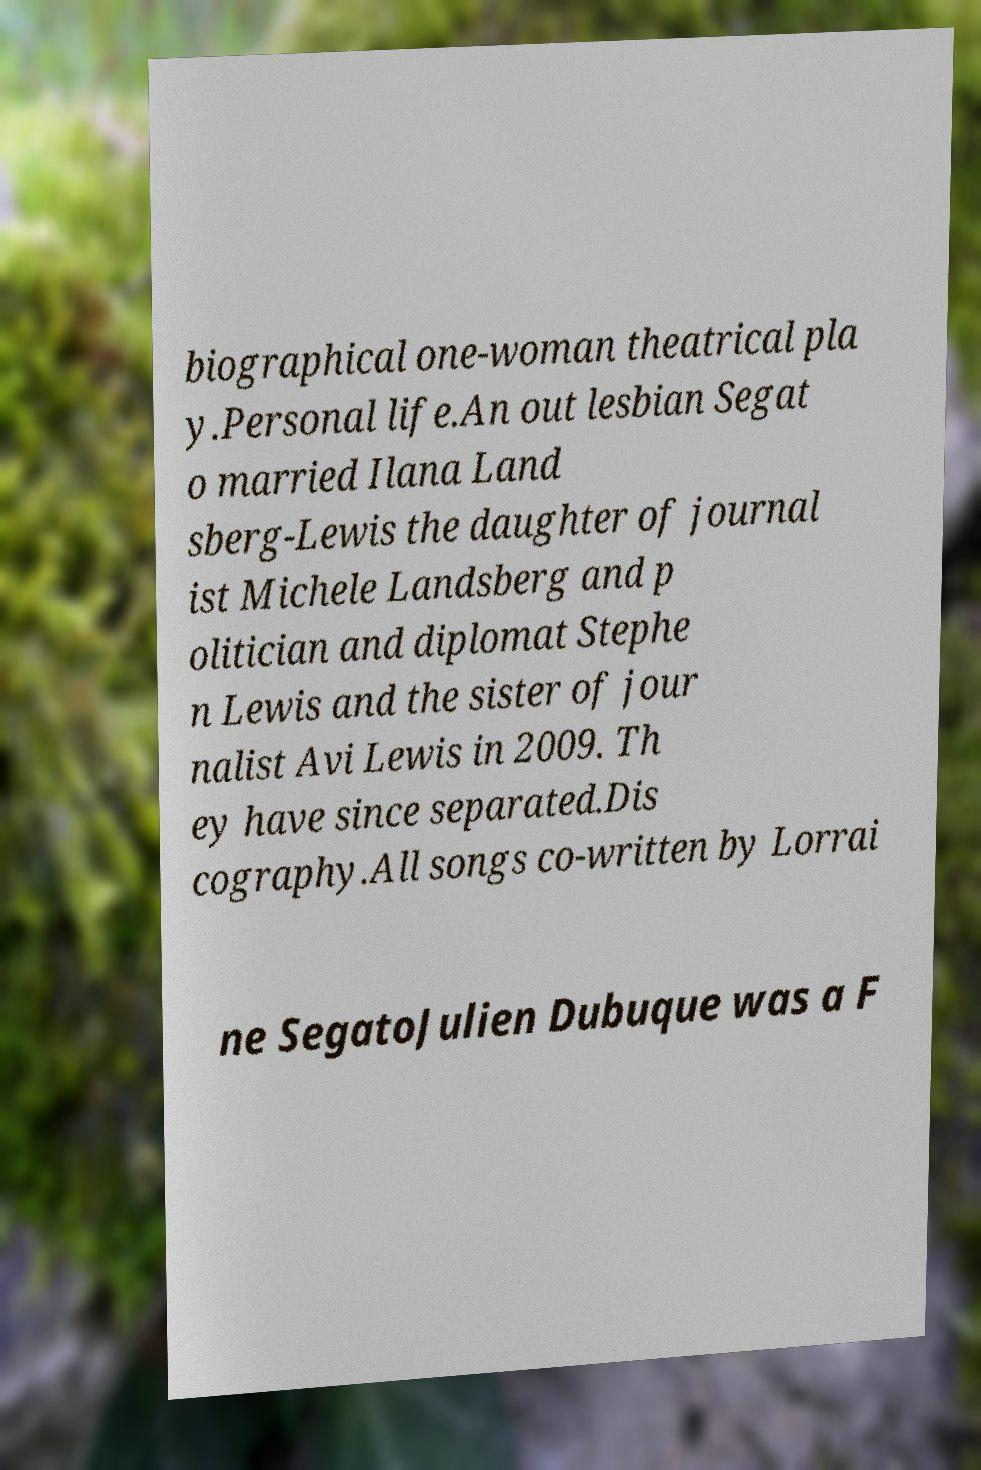Please identify and transcribe the text found in this image. biographical one-woman theatrical pla y.Personal life.An out lesbian Segat o married Ilana Land sberg-Lewis the daughter of journal ist Michele Landsberg and p olitician and diplomat Stephe n Lewis and the sister of jour nalist Avi Lewis in 2009. Th ey have since separated.Dis cography.All songs co-written by Lorrai ne SegatoJulien Dubuque was a F 